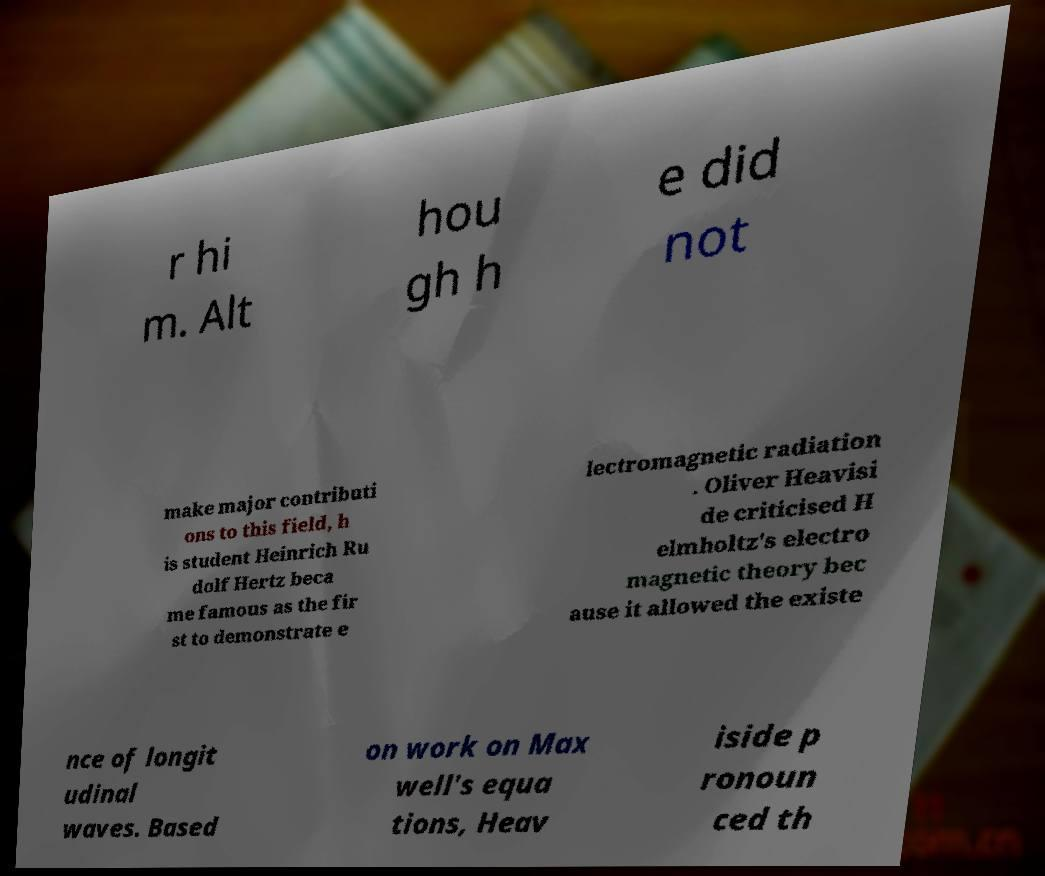Can you accurately transcribe the text from the provided image for me? r hi m. Alt hou gh h e did not make major contributi ons to this field, h is student Heinrich Ru dolf Hertz beca me famous as the fir st to demonstrate e lectromagnetic radiation . Oliver Heavisi de criticised H elmholtz's electro magnetic theory bec ause it allowed the existe nce of longit udinal waves. Based on work on Max well's equa tions, Heav iside p ronoun ced th 